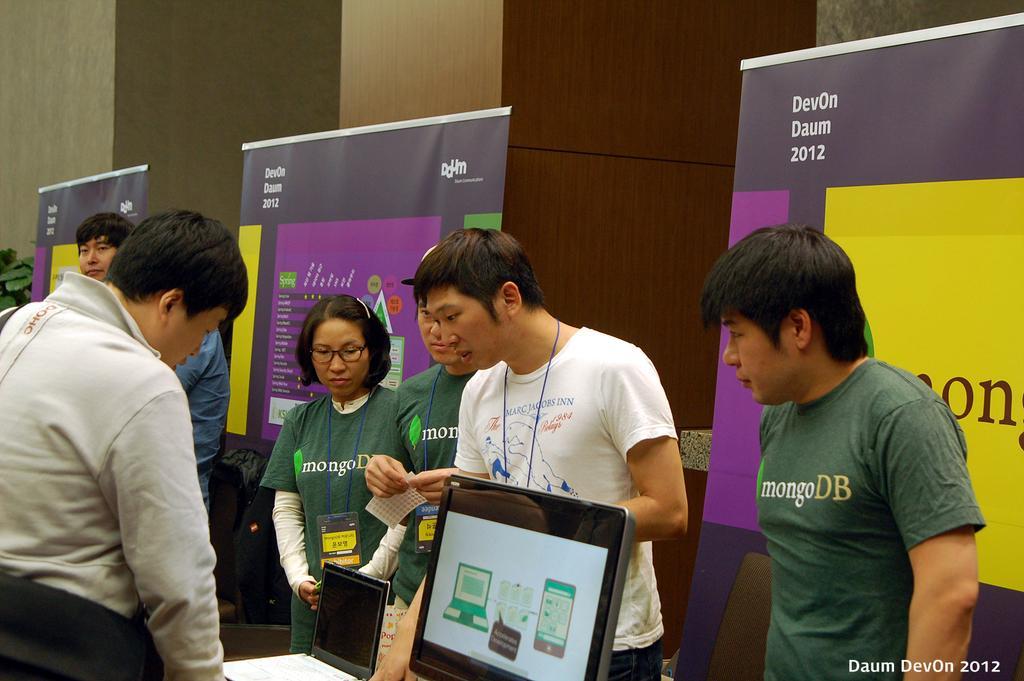How would you summarize this image in a sentence or two? Here we can see few persons are standing and there is a monitor and laptop. In the background there are hoardings,wall and a plant on the left side. 